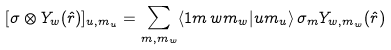<formula> <loc_0><loc_0><loc_500><loc_500>[ \sigma \otimes Y _ { w } ( \hat { r } ) ] _ { u , m _ { u } } = \sum _ { m , m _ { w } } \langle 1 m \, w m _ { w } | u m _ { u } \rangle \, \sigma _ { m } Y _ { w , m _ { w } } ( \hat { r } )</formula> 